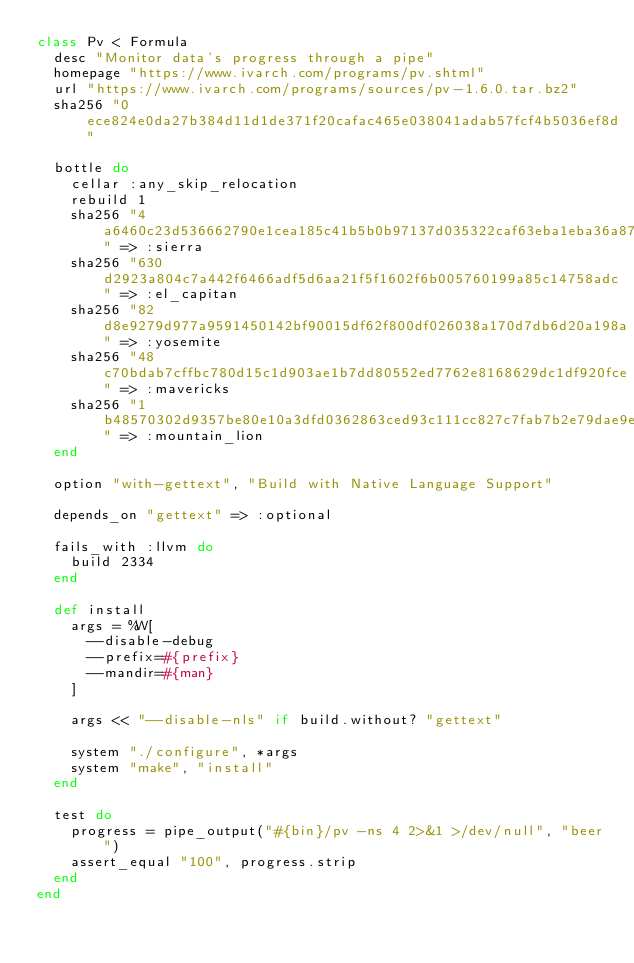<code> <loc_0><loc_0><loc_500><loc_500><_Ruby_>class Pv < Formula
  desc "Monitor data's progress through a pipe"
  homepage "https://www.ivarch.com/programs/pv.shtml"
  url "https://www.ivarch.com/programs/sources/pv-1.6.0.tar.bz2"
  sha256 "0ece824e0da27b384d11d1de371f20cafac465e038041adab57fcf4b5036ef8d"

  bottle do
    cellar :any_skip_relocation
    rebuild 1
    sha256 "4a6460c23d536662790e1cea185c41b5b0b97137d035322caf63eba1eba36a87" => :sierra
    sha256 "630d2923a804c7a442f6466adf5d6aa21f5f1602f6b005760199a85c14758adc" => :el_capitan
    sha256 "82d8e9279d977a9591450142bf90015df62f800df026038a170d7db6d20a198a" => :yosemite
    sha256 "48c70bdab7cffbc780d15c1d903ae1b7dd80552ed7762e8168629dc1df920fce" => :mavericks
    sha256 "1b48570302d9357be80e10a3dfd0362863ced93c111cc827c7fab7b2e79dae9e" => :mountain_lion
  end

  option "with-gettext", "Build with Native Language Support"

  depends_on "gettext" => :optional

  fails_with :llvm do
    build 2334
  end

  def install
    args = %W[
      --disable-debug
      --prefix=#{prefix}
      --mandir=#{man}
    ]

    args << "--disable-nls" if build.without? "gettext"

    system "./configure", *args
    system "make", "install"
  end

  test do
    progress = pipe_output("#{bin}/pv -ns 4 2>&1 >/dev/null", "beer")
    assert_equal "100", progress.strip
  end
end
</code> 